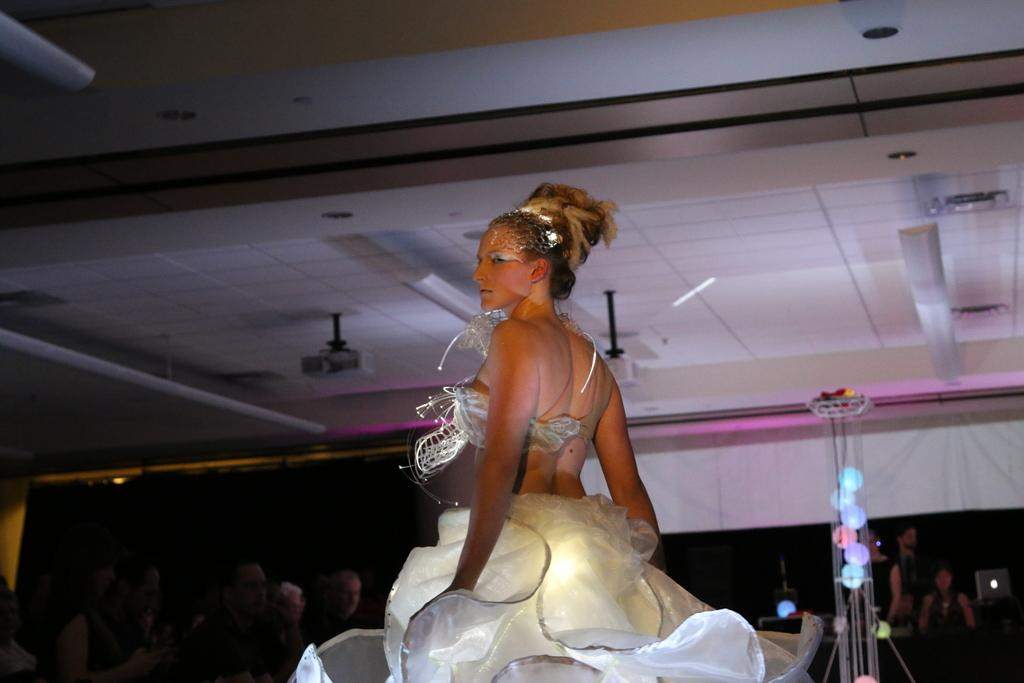Who is the main subject in the image? There is a lady standing in the center of the image. What is the lady wearing? The lady is wearing a costume. What can be seen in the background of the image? There are people in the background of the image. What is present on the right side of the image? There is a decor on the right side of the image. What is visible at the top of the image? There are lights visible at the top of the image. How many ants can be seen carrying the lady's costume in the image? There are no ants present in the image, and they are not carrying the lady's costume. What color is the trip depicted in the image? There is no trip depicted in the image; it features a lady standing in the center wearing a costume. 